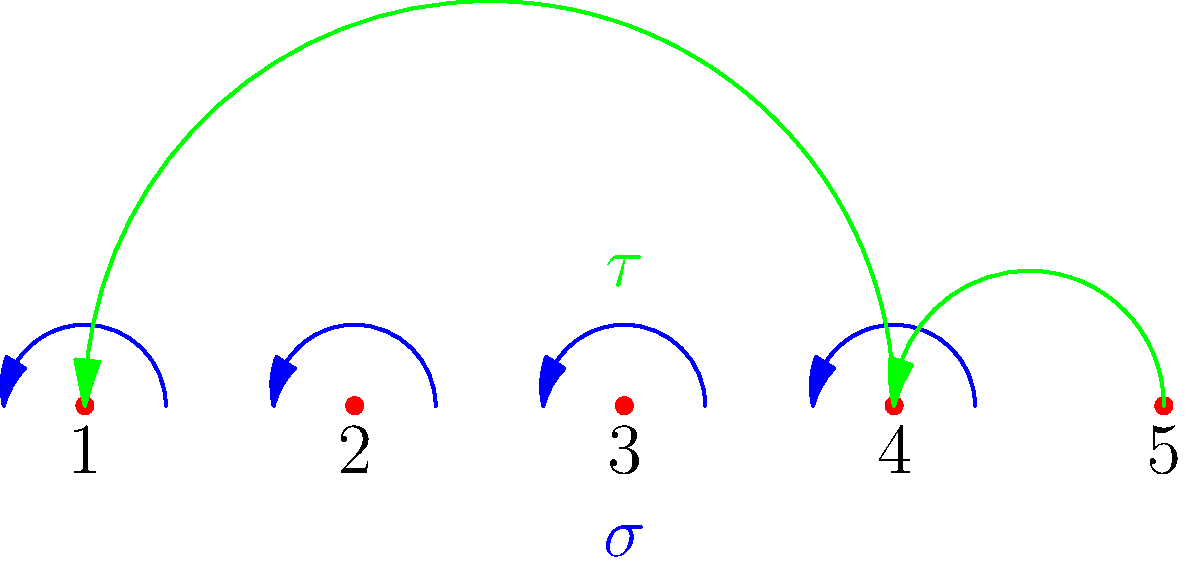Consider two permutations in cycle notation: $\sigma = (1 2 3 4 5)$ and $\tau = (2 3 4)(5)$. What is the result of the composition $\sigma \circ \tau$ in cycle notation? To find the composition $\sigma \circ \tau$, we follow these steps:

1) Start with any element and apply $\tau$ first, then $\sigma$.

2) Let's start with 1:
   $1 \xrightarrow{\tau} 1$ (1 is not moved by $\tau$)
   $1 \xrightarrow{\sigma} 2$

3) Continue with 2:
   $2 \xrightarrow{\tau} 3$
   $3 \xrightarrow{\sigma} 4$

4) Continue with 4:
   $4 \xrightarrow{\tau} 2$ (cycle back in $\tau$)
   $2 \xrightarrow{\sigma} 3$

5) Continue with 3:
   $3 \xrightarrow{\tau} 4$
   $4 \xrightarrow{\sigma} 5$

6) Finally, 5:
   $5 \xrightarrow{\tau} 5$ (5 is not moved by $\tau$)
   $5 \xrightarrow{\sigma} 1$

7) We're back at 1, so the cycle is complete.

Therefore, the composition $\sigma \circ \tau$ maps:
$1 \to 2 \to 3 \to 4 \to 5 \to 1$
Answer: $(1 2 3 4 5)$ 